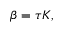Convert formula to latex. <formula><loc_0><loc_0><loc_500><loc_500>\beta = \tau K ,</formula> 